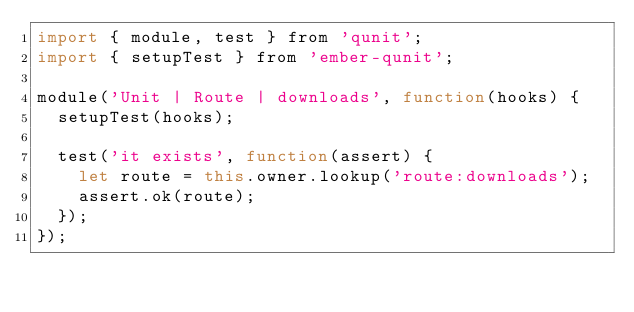<code> <loc_0><loc_0><loc_500><loc_500><_JavaScript_>import { module, test } from 'qunit';
import { setupTest } from 'ember-qunit';

module('Unit | Route | downloads', function(hooks) {
  setupTest(hooks);

  test('it exists', function(assert) {
    let route = this.owner.lookup('route:downloads');
    assert.ok(route);
  });
});
</code> 